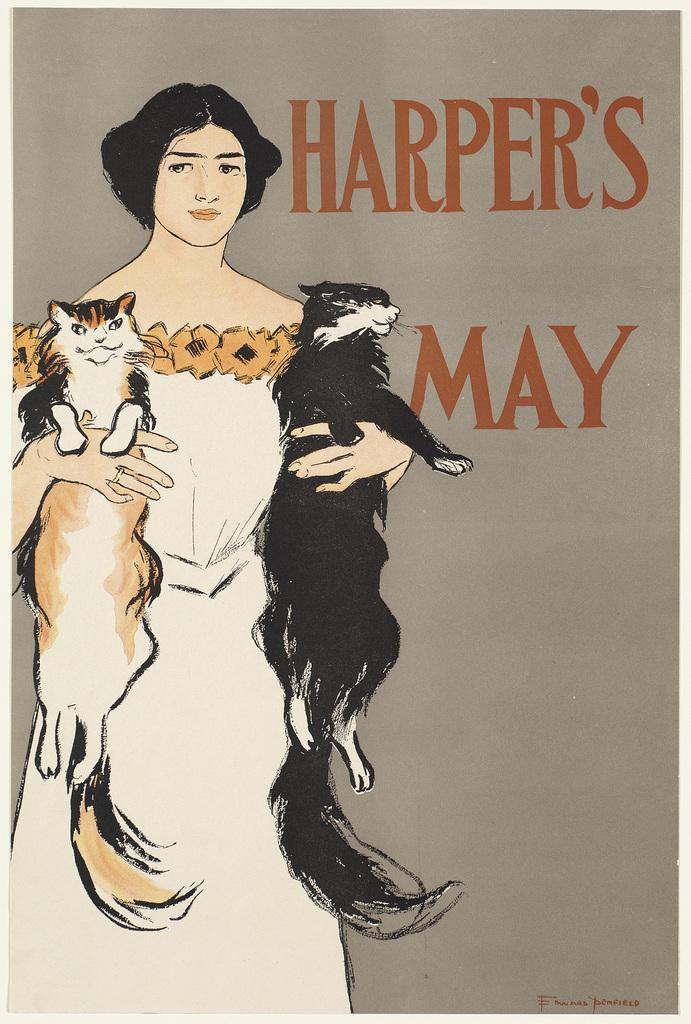Who is present in the image? There is a woman in the image. What is the woman holding in the image? The woman is holding two cats. Can you describe anything else visible in the image? There is text on the right side of the image. What type of desire is the woman expressing in the image? There is no indication of any desire being expressed in the image; it simply shows a woman holding two cats. 